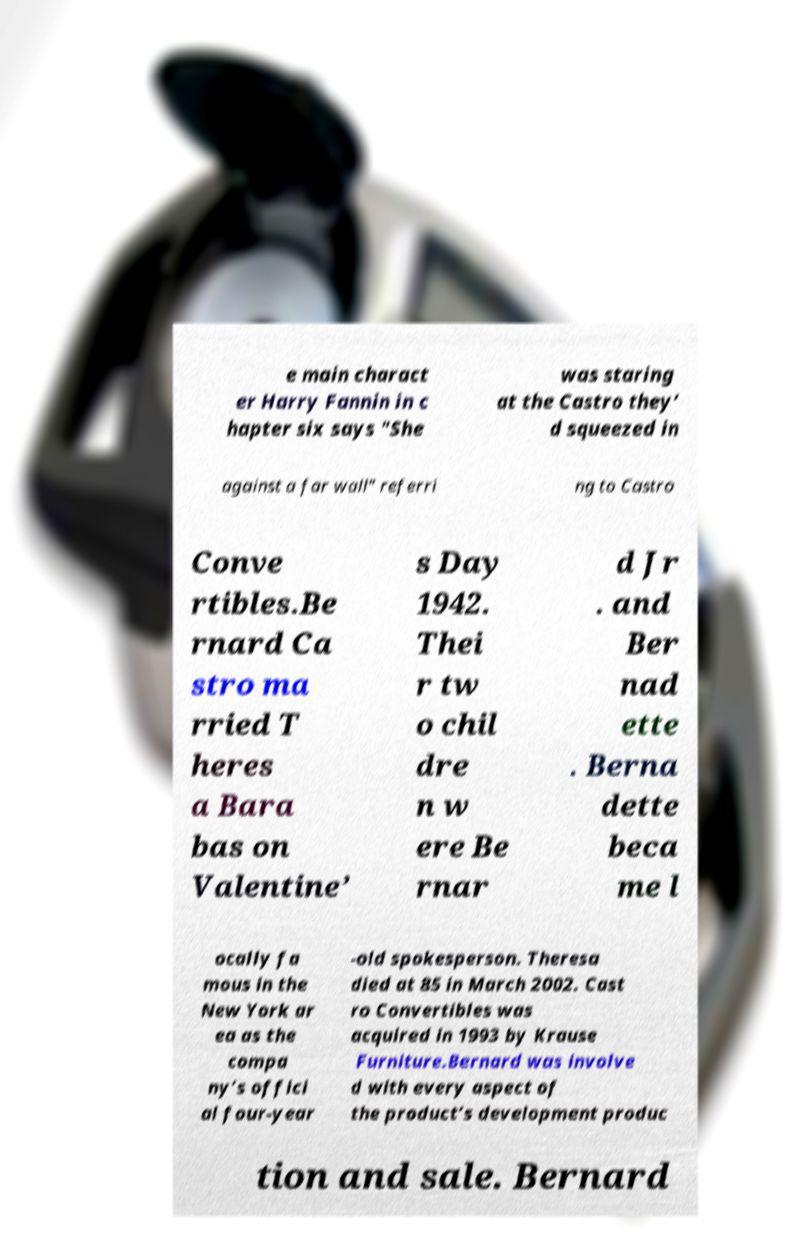Please identify and transcribe the text found in this image. e main charact er Harry Fannin in c hapter six says "She was staring at the Castro they’ d squeezed in against a far wall" referri ng to Castro Conve rtibles.Be rnard Ca stro ma rried T heres a Bara bas on Valentine’ s Day 1942. Thei r tw o chil dre n w ere Be rnar d Jr . and Ber nad ette . Berna dette beca me l ocally fa mous in the New York ar ea as the compa ny’s offici al four-year -old spokesperson. Theresa died at 85 in March 2002. Cast ro Convertibles was acquired in 1993 by Krause Furniture.Bernard was involve d with every aspect of the product’s development produc tion and sale. Bernard 